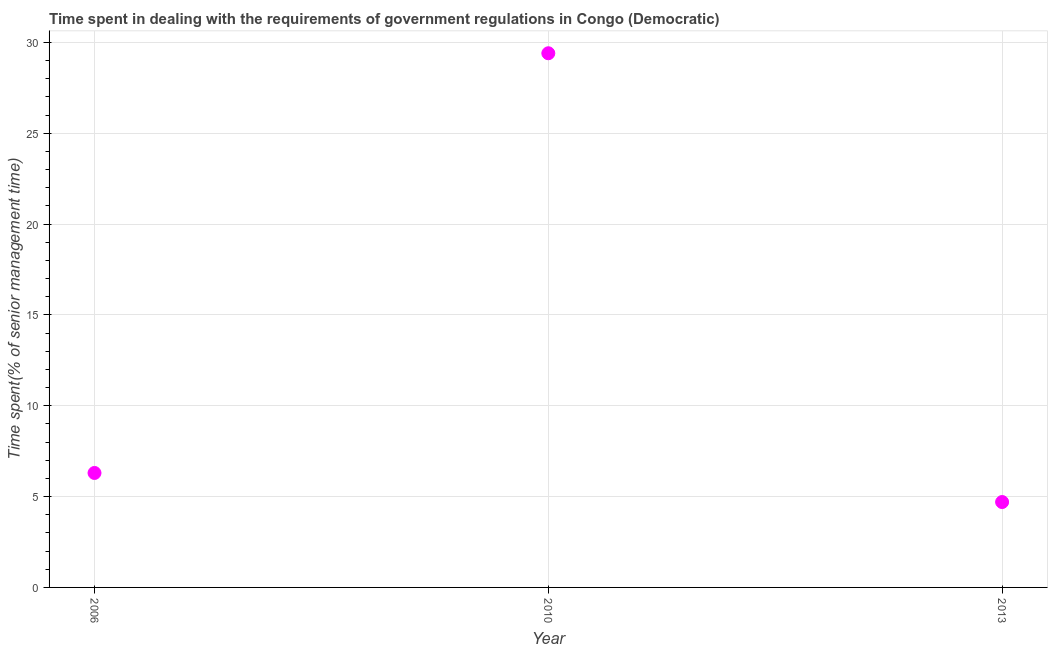What is the time spent in dealing with government regulations in 2013?
Your answer should be very brief. 4.7. Across all years, what is the maximum time spent in dealing with government regulations?
Provide a short and direct response. 29.4. Across all years, what is the minimum time spent in dealing with government regulations?
Offer a terse response. 4.7. In which year was the time spent in dealing with government regulations maximum?
Offer a very short reply. 2010. In which year was the time spent in dealing with government regulations minimum?
Your response must be concise. 2013. What is the sum of the time spent in dealing with government regulations?
Make the answer very short. 40.4. What is the difference between the time spent in dealing with government regulations in 2006 and 2013?
Provide a short and direct response. 1.6. What is the average time spent in dealing with government regulations per year?
Ensure brevity in your answer.  13.47. What is the median time spent in dealing with government regulations?
Provide a succinct answer. 6.3. What is the ratio of the time spent in dealing with government regulations in 2010 to that in 2013?
Your answer should be very brief. 6.26. What is the difference between the highest and the second highest time spent in dealing with government regulations?
Your answer should be compact. 23.1. What is the difference between the highest and the lowest time spent in dealing with government regulations?
Provide a short and direct response. 24.7. Are the values on the major ticks of Y-axis written in scientific E-notation?
Provide a short and direct response. No. What is the title of the graph?
Offer a terse response. Time spent in dealing with the requirements of government regulations in Congo (Democratic). What is the label or title of the Y-axis?
Offer a terse response. Time spent(% of senior management time). What is the Time spent(% of senior management time) in 2010?
Offer a very short reply. 29.4. What is the Time spent(% of senior management time) in 2013?
Offer a very short reply. 4.7. What is the difference between the Time spent(% of senior management time) in 2006 and 2010?
Your answer should be compact. -23.1. What is the difference between the Time spent(% of senior management time) in 2006 and 2013?
Offer a very short reply. 1.6. What is the difference between the Time spent(% of senior management time) in 2010 and 2013?
Ensure brevity in your answer.  24.7. What is the ratio of the Time spent(% of senior management time) in 2006 to that in 2010?
Ensure brevity in your answer.  0.21. What is the ratio of the Time spent(% of senior management time) in 2006 to that in 2013?
Keep it short and to the point. 1.34. What is the ratio of the Time spent(% of senior management time) in 2010 to that in 2013?
Ensure brevity in your answer.  6.25. 